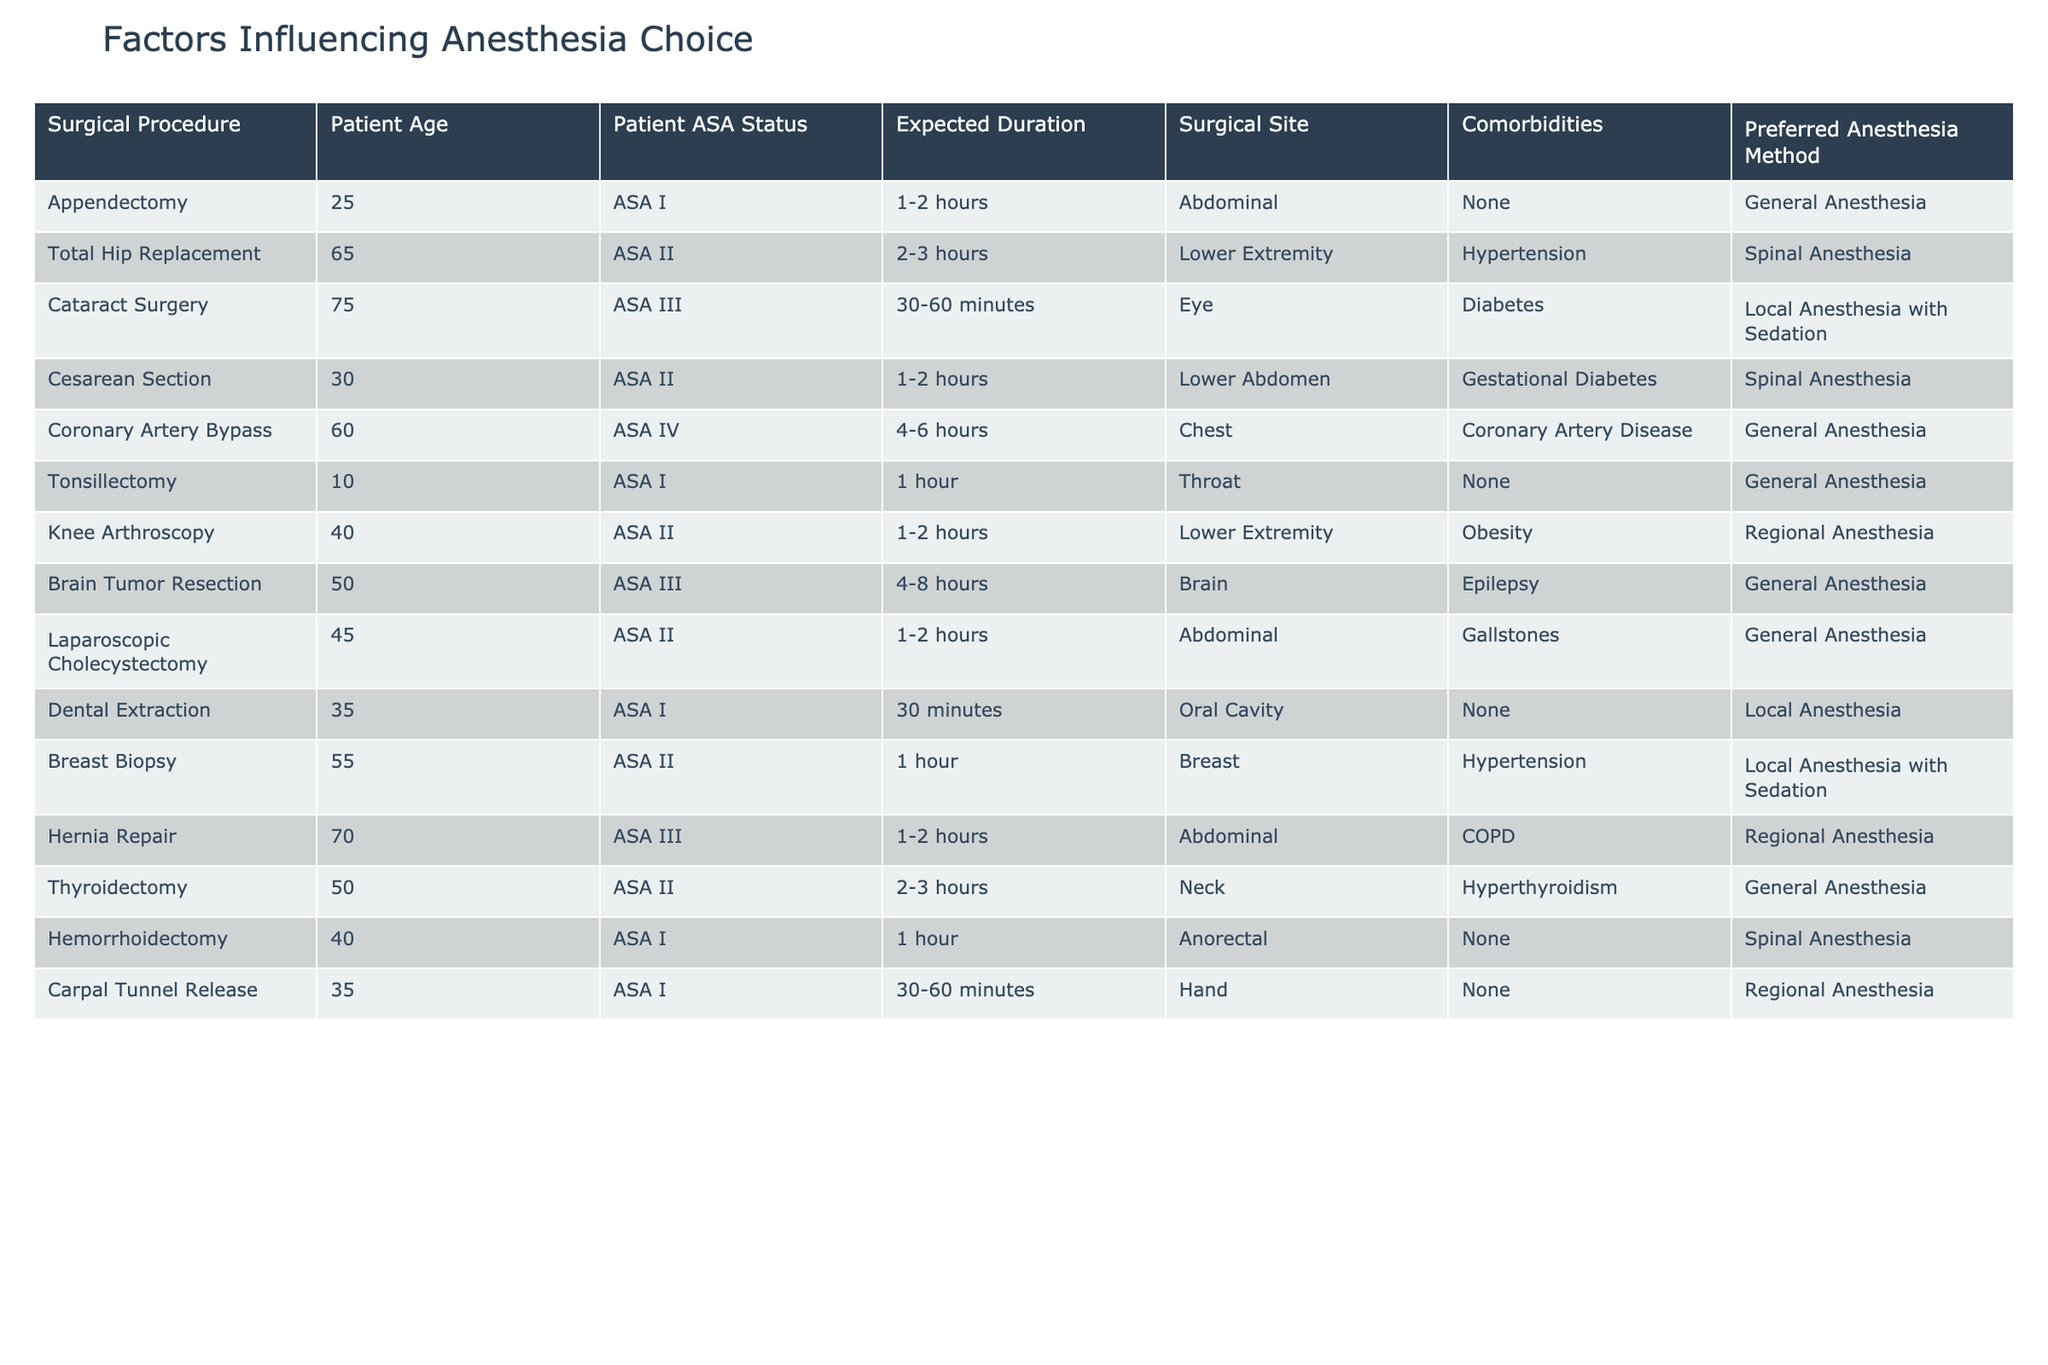What anesthesia method is preferred for cataract surgery? The table indicates that for cataract surgery, the preferred anesthesia method is local anesthesia with sedation. This is found in the row corresponding to cataract surgery in the "Preferred Anesthesia Method" column.
Answer: Local Anesthesia with Sedation Which surgical procedure is associated with Spinal Anesthesia? There are two surgical procedures associated with Spinal Anesthesia: Cesarean Section and Hemorrhoidectomy. This can be found by scanning the table for the appearances of Spinal Anesthesia in the "Preferred Anesthesia Method" column and identifying the corresponding surgical procedures.
Answer: Cesarean Section and Hemorrhoidectomy Is the expected duration for a total hip replacement longer than 2 hours? According to the table, the expected duration for a total hip replacement is listed as 2-3 hours. Since 2-3 hours includes durations longer than 2 hours, we can conclude that this statement is true.
Answer: Yes What is the average age of patients undergoing surgeries that use General Anesthesia? First, we identify the patients requiring General Anesthesia: appendectomy (25), coronary artery bypass (60), tonsillectomy (10), brain tumor resection (50), laparoscopic cholecystectomy (45), and thyroidectomy (50). We then calculate the average: (25 + 60 + 10 + 50 + 45 + 50) = 240. There are 6 patients, so the average age is 240 / 6 = 40.
Answer: 40 How many patients with Diabetes are having surgery and what procedures are they undergoing? From the table, only one surgical procedure has a patient with diabetes, which is cataract surgery. We can filter the table for the "Comorbidities" column to identify patients with diabetes and determine the corresponding surgical procedure.
Answer: Cataract Surgery What percentage of surgical procedures listed require Regional Anesthesia? There are 2 procedures requiring Regional Anesthesia (Knee arthroscopy and Hernia repair) out of a total of 15 procedures. The percentage is calculated as (2/15) * 100 = 13.33%.
Answer: 13.33% Is there any surgical procedure listed that is associated with an ASA IV status? The table indicates that the coronary artery bypass is associated with ASA IV status. By checking the "Patient ASA Status" column, we find this specific case.
Answer: Yes What is the main surgery type preferred for patients with hypertension based on this table? Upon reviewing the table, patients with hypertension are scheduled for two procedures: total hip replacement and breast biopsy. Therefore, surgeries involving these procedures are primarily preferred for patients with hypertension.
Answer: Total Hip Replacement and Breast Biopsy 